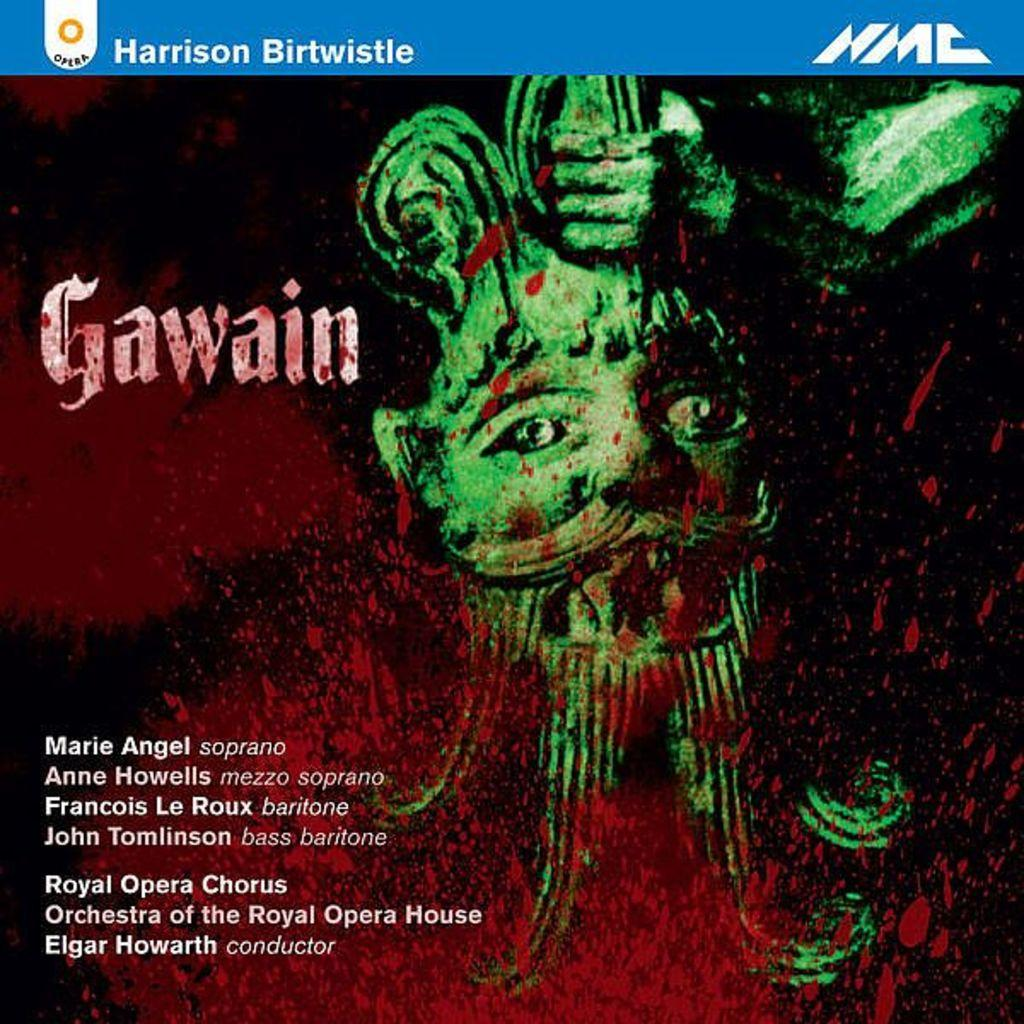What can be seen on the poster in the image? There is a poster in the image, and text is written on the bottom left side of the poster. What other objects are present in the image besides the poster? There is a statue and a painting in the image. Can you describe the painting in the image? The painting in the image is green in color. How many birds are flying in the image? There are no birds visible in the image. What type of cloud can be seen in the image? There are no clouds visible in the image. 